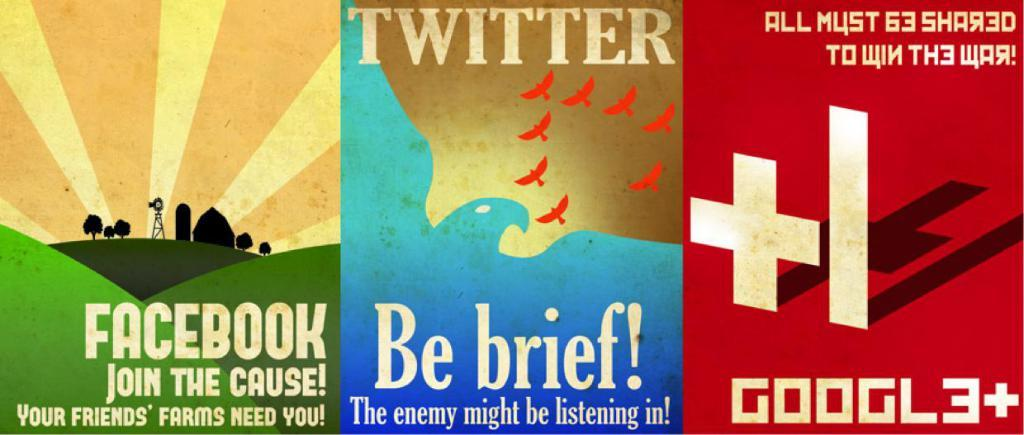<image>
Write a terse but informative summary of the picture. The middle poster is titled by the company Twitter 